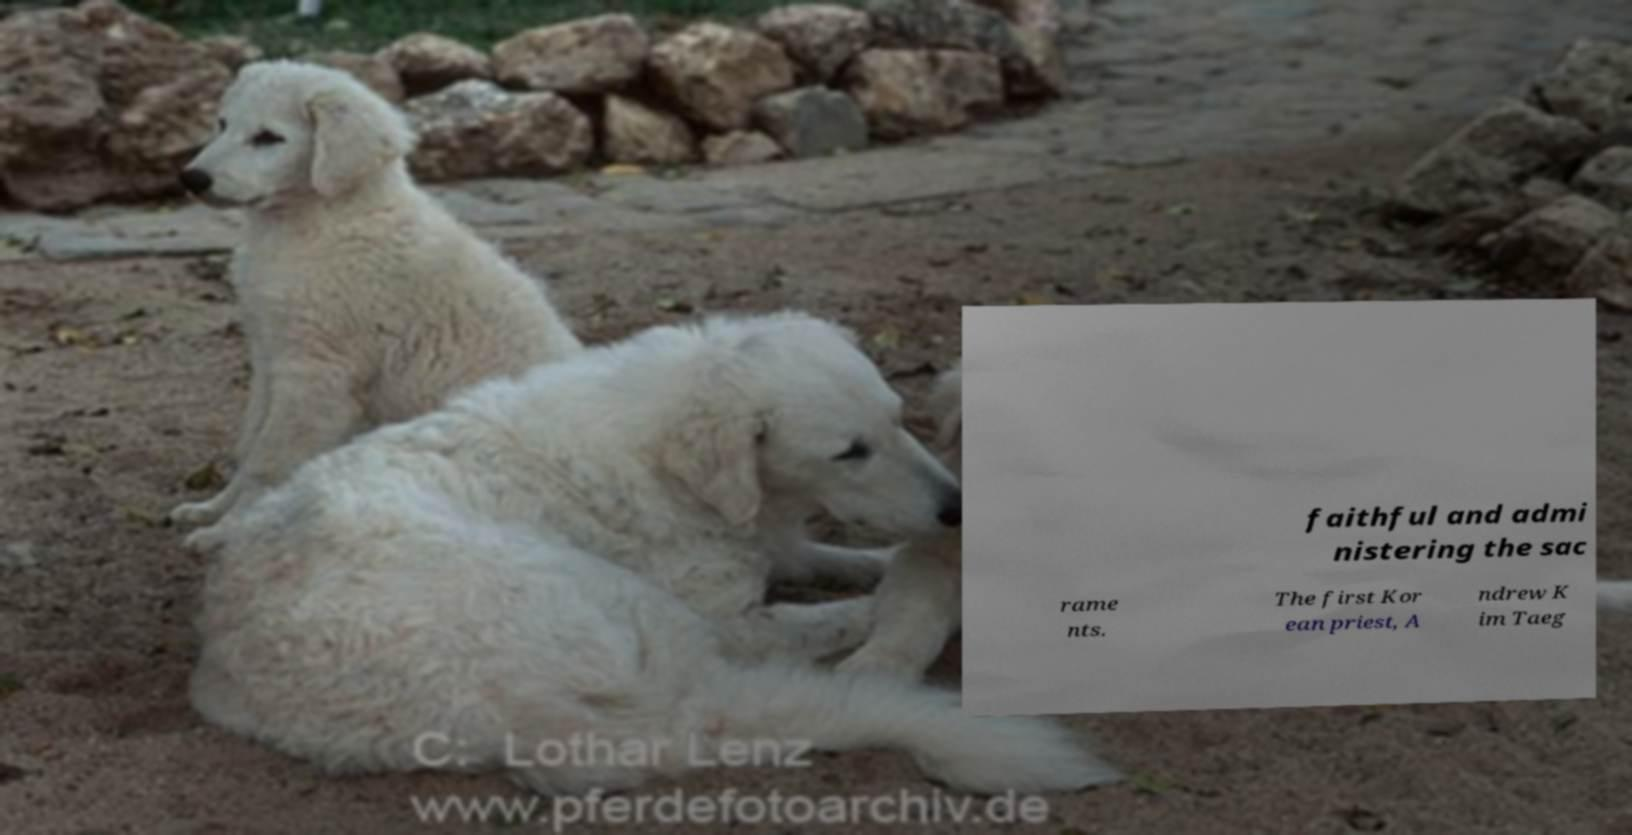Could you assist in decoding the text presented in this image and type it out clearly? faithful and admi nistering the sac rame nts. The first Kor ean priest, A ndrew K im Taeg 